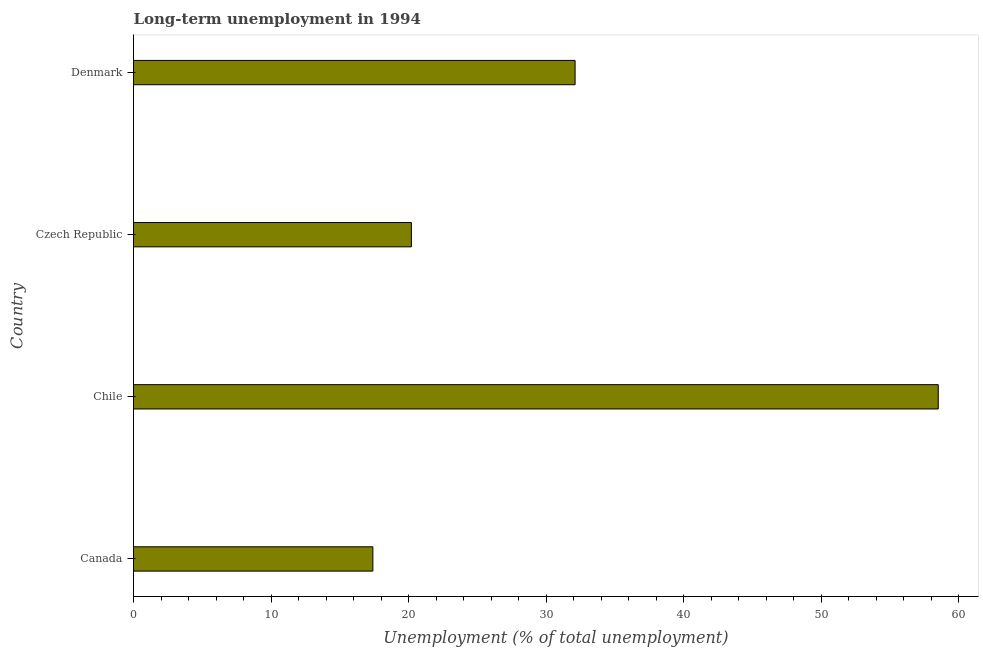Does the graph contain any zero values?
Give a very brief answer. No. Does the graph contain grids?
Offer a very short reply. No. What is the title of the graph?
Provide a short and direct response. Long-term unemployment in 1994. What is the label or title of the X-axis?
Keep it short and to the point. Unemployment (% of total unemployment). What is the long-term unemployment in Canada?
Give a very brief answer. 17.4. Across all countries, what is the maximum long-term unemployment?
Offer a terse response. 58.5. Across all countries, what is the minimum long-term unemployment?
Provide a short and direct response. 17.4. In which country was the long-term unemployment maximum?
Make the answer very short. Chile. In which country was the long-term unemployment minimum?
Offer a terse response. Canada. What is the sum of the long-term unemployment?
Offer a very short reply. 128.2. What is the average long-term unemployment per country?
Keep it short and to the point. 32.05. What is the median long-term unemployment?
Make the answer very short. 26.15. In how many countries, is the long-term unemployment greater than 4 %?
Offer a very short reply. 4. What is the ratio of the long-term unemployment in Canada to that in Chile?
Your answer should be compact. 0.3. Is the long-term unemployment in Canada less than that in Chile?
Your response must be concise. Yes. What is the difference between the highest and the second highest long-term unemployment?
Offer a very short reply. 26.4. What is the difference between the highest and the lowest long-term unemployment?
Keep it short and to the point. 41.1. How many bars are there?
Ensure brevity in your answer.  4. Are all the bars in the graph horizontal?
Provide a succinct answer. Yes. What is the difference between two consecutive major ticks on the X-axis?
Offer a terse response. 10. What is the Unemployment (% of total unemployment) in Canada?
Provide a succinct answer. 17.4. What is the Unemployment (% of total unemployment) in Chile?
Offer a very short reply. 58.5. What is the Unemployment (% of total unemployment) of Czech Republic?
Ensure brevity in your answer.  20.2. What is the Unemployment (% of total unemployment) in Denmark?
Provide a succinct answer. 32.1. What is the difference between the Unemployment (% of total unemployment) in Canada and Chile?
Make the answer very short. -41.1. What is the difference between the Unemployment (% of total unemployment) in Canada and Denmark?
Offer a terse response. -14.7. What is the difference between the Unemployment (% of total unemployment) in Chile and Czech Republic?
Keep it short and to the point. 38.3. What is the difference between the Unemployment (% of total unemployment) in Chile and Denmark?
Your response must be concise. 26.4. What is the difference between the Unemployment (% of total unemployment) in Czech Republic and Denmark?
Ensure brevity in your answer.  -11.9. What is the ratio of the Unemployment (% of total unemployment) in Canada to that in Chile?
Keep it short and to the point. 0.3. What is the ratio of the Unemployment (% of total unemployment) in Canada to that in Czech Republic?
Provide a succinct answer. 0.86. What is the ratio of the Unemployment (% of total unemployment) in Canada to that in Denmark?
Offer a terse response. 0.54. What is the ratio of the Unemployment (% of total unemployment) in Chile to that in Czech Republic?
Your response must be concise. 2.9. What is the ratio of the Unemployment (% of total unemployment) in Chile to that in Denmark?
Give a very brief answer. 1.82. What is the ratio of the Unemployment (% of total unemployment) in Czech Republic to that in Denmark?
Your response must be concise. 0.63. 